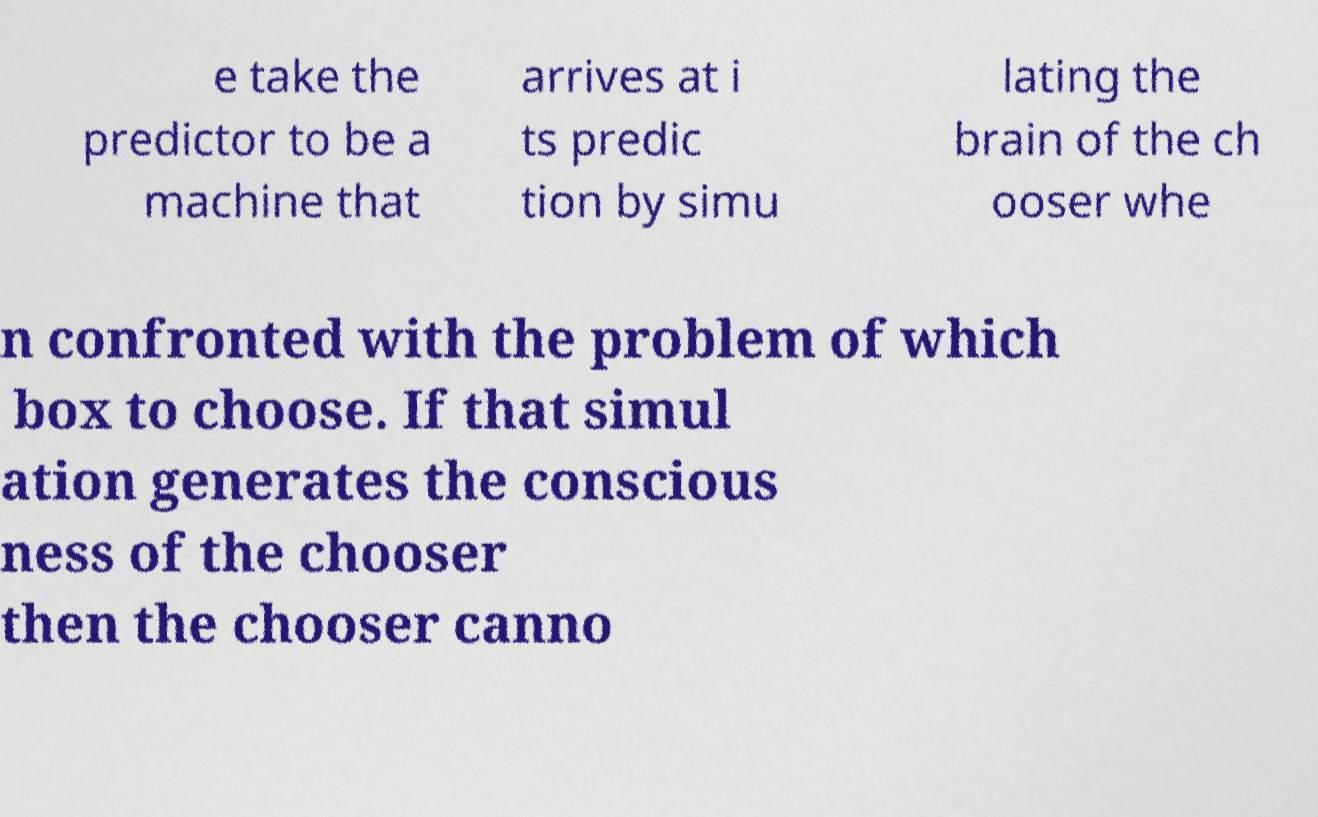What messages or text are displayed in this image? I need them in a readable, typed format. e take the predictor to be a machine that arrives at i ts predic tion by simu lating the brain of the ch ooser whe n confronted with the problem of which box to choose. If that simul ation generates the conscious ness of the chooser then the chooser canno 